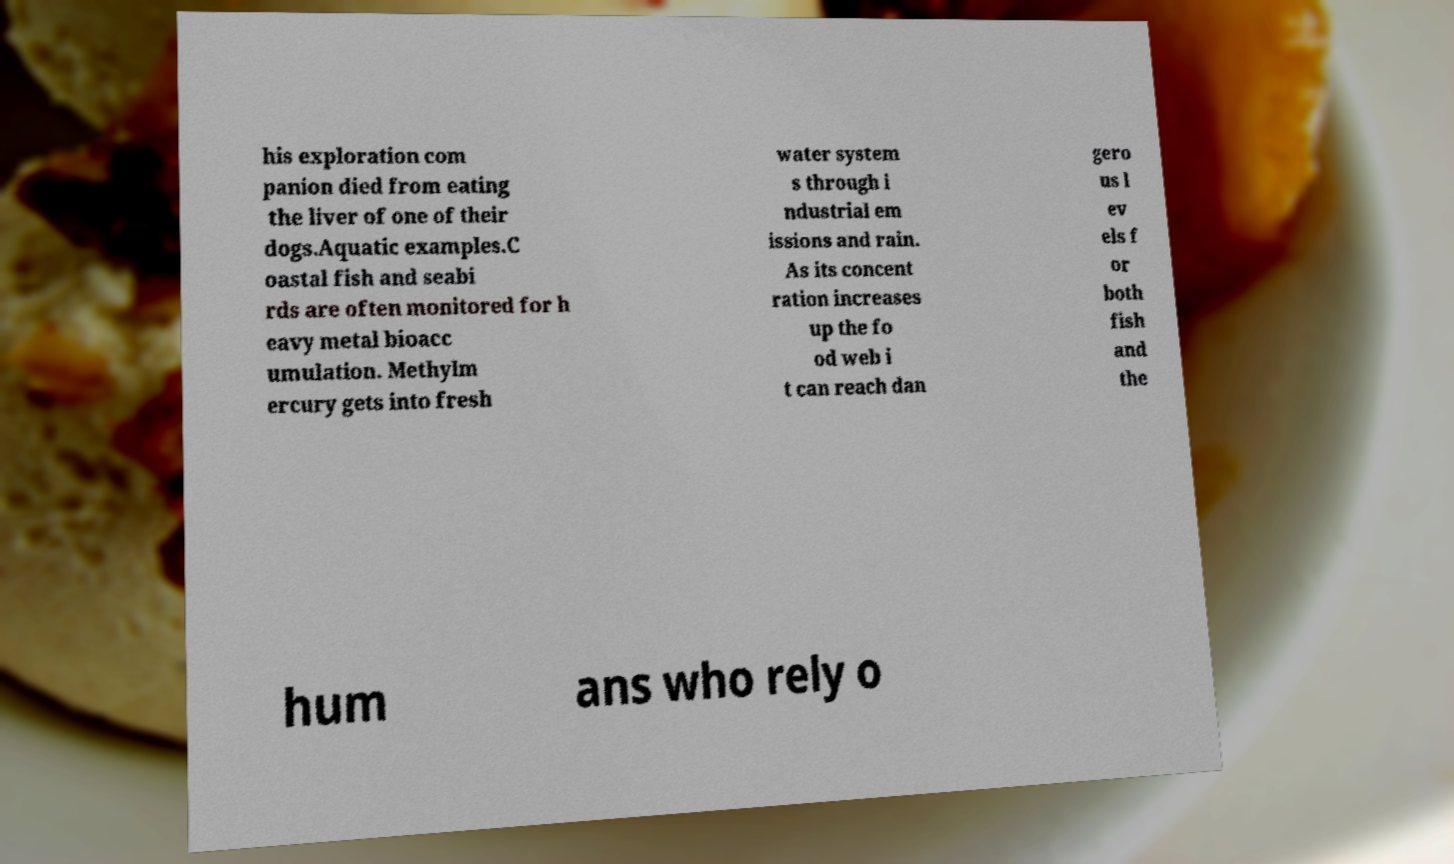For documentation purposes, I need the text within this image transcribed. Could you provide that? his exploration com panion died from eating the liver of one of their dogs.Aquatic examples.C oastal fish and seabi rds are often monitored for h eavy metal bioacc umulation. Methylm ercury gets into fresh water system s through i ndustrial em issions and rain. As its concent ration increases up the fo od web i t can reach dan gero us l ev els f or both fish and the hum ans who rely o 